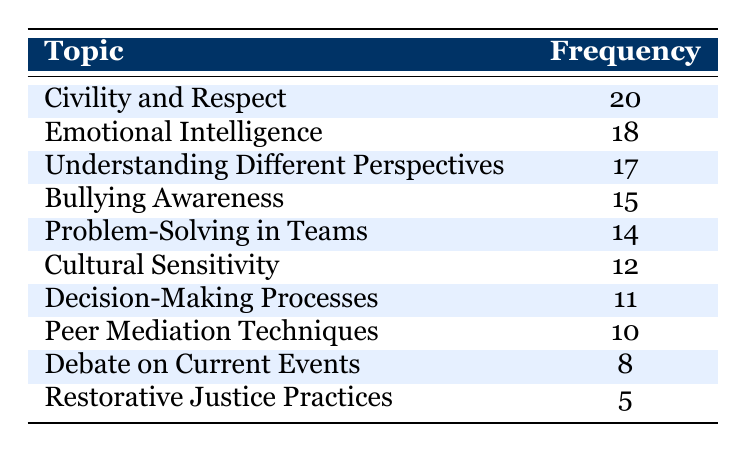What is the most discussed topic in the classroom regarding conflict resolution? The table shows the frequency of discussions for each topic. The topic with the highest frequency is "Civility and Respect" at a frequency of 20.
Answer: Civility and Respect What is the frequency of discussions on "Cultural Sensitivity"? Referring to the table, "Cultural Sensitivity" has a frequency of 12 discussions.
Answer: 12 How many topics have a frequency greater than 15? We need to identify the topics with a frequency greater than 15 from the table. The topics are "Civility and Respect" (20), "Emotional Intelligence" (18), and "Understanding Different Perspectives" (17). That's a total of 3 topics.
Answer: 3 What is the average frequency of discussions across all topics? To calculate the average, we sum the frequencies: (20 + 18 + 17 + 15 + 14 + 12 + 11 + 10 + 8 + 5) = 120. There are 10 topics, so the average frequency is 120/10 = 12.
Answer: 12 Is "Restorative Justice Practices" discussed more frequently than "Debate on Current Events"? The table shows "Restorative Justice Practices" has a frequency of 5 and "Debate on Current Events" has a frequency of 8. Since 5 is less than 8, the statement is false.
Answer: No What is the difference in frequency between the topics "Emotional Intelligence" and "Peer Mediation Techniques"? The frequency of "Emotional Intelligence" is 18 and for "Peer Mediation Techniques" it is 10. The difference is calculated as 18 - 10 = 8.
Answer: 8 How many discussions were focused on "Bullying Awareness" and "Problem-Solving in Teams" combined? Adding the frequencies together, for "Bullying Awareness" (15) and "Problem-Solving in Teams" (14), we have 15 + 14 = 29 discussions altogether.
Answer: 29 Which topic had the lowest discussion frequency? Referring to the table, "Restorative Justice Practices" has the lowest frequency with 5 discussions.
Answer: Restorative Justice Practices What is the total frequency of discussions on "Understanding Different Perspectives" and "Civility and Respect"? The frequency for "Understanding Different Perspectives" is 17 and for "Civility and Respect" it is 20. Adding these gives us 17 + 20 = 37.
Answer: 37 